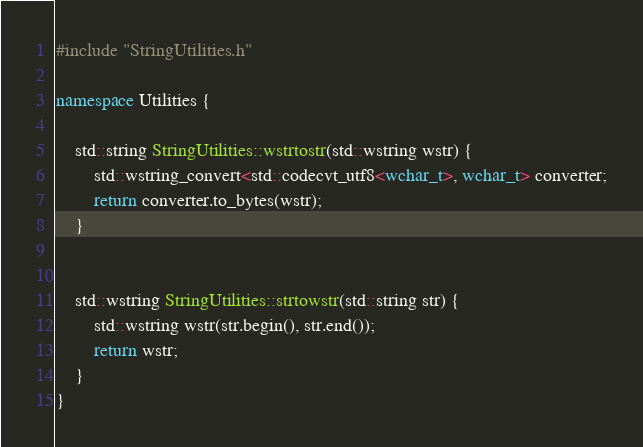Convert code to text. <code><loc_0><loc_0><loc_500><loc_500><_C++_>#include "StringUtilities.h"

namespace Utilities {
	
	std::string StringUtilities::wstrtostr(std::wstring wstr) {
		std::wstring_convert<std::codecvt_utf8<wchar_t>, wchar_t> converter;
		return converter.to_bytes(wstr);
	}


	std::wstring StringUtilities::strtowstr(std::string str) {
		std::wstring wstr(str.begin(), str.end());
		return wstr;
	}
}
</code> 